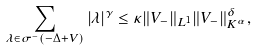<formula> <loc_0><loc_0><loc_500><loc_500>\sum _ { \lambda \in \sigma ^ { - } ( - \Delta + V ) } | \lambda | ^ { \gamma } \leq \kappa \| V _ { - } \| _ { L ^ { 1 } } \| V _ { - } \| _ { K ^ { \alpha } } ^ { \delta } ,</formula> 